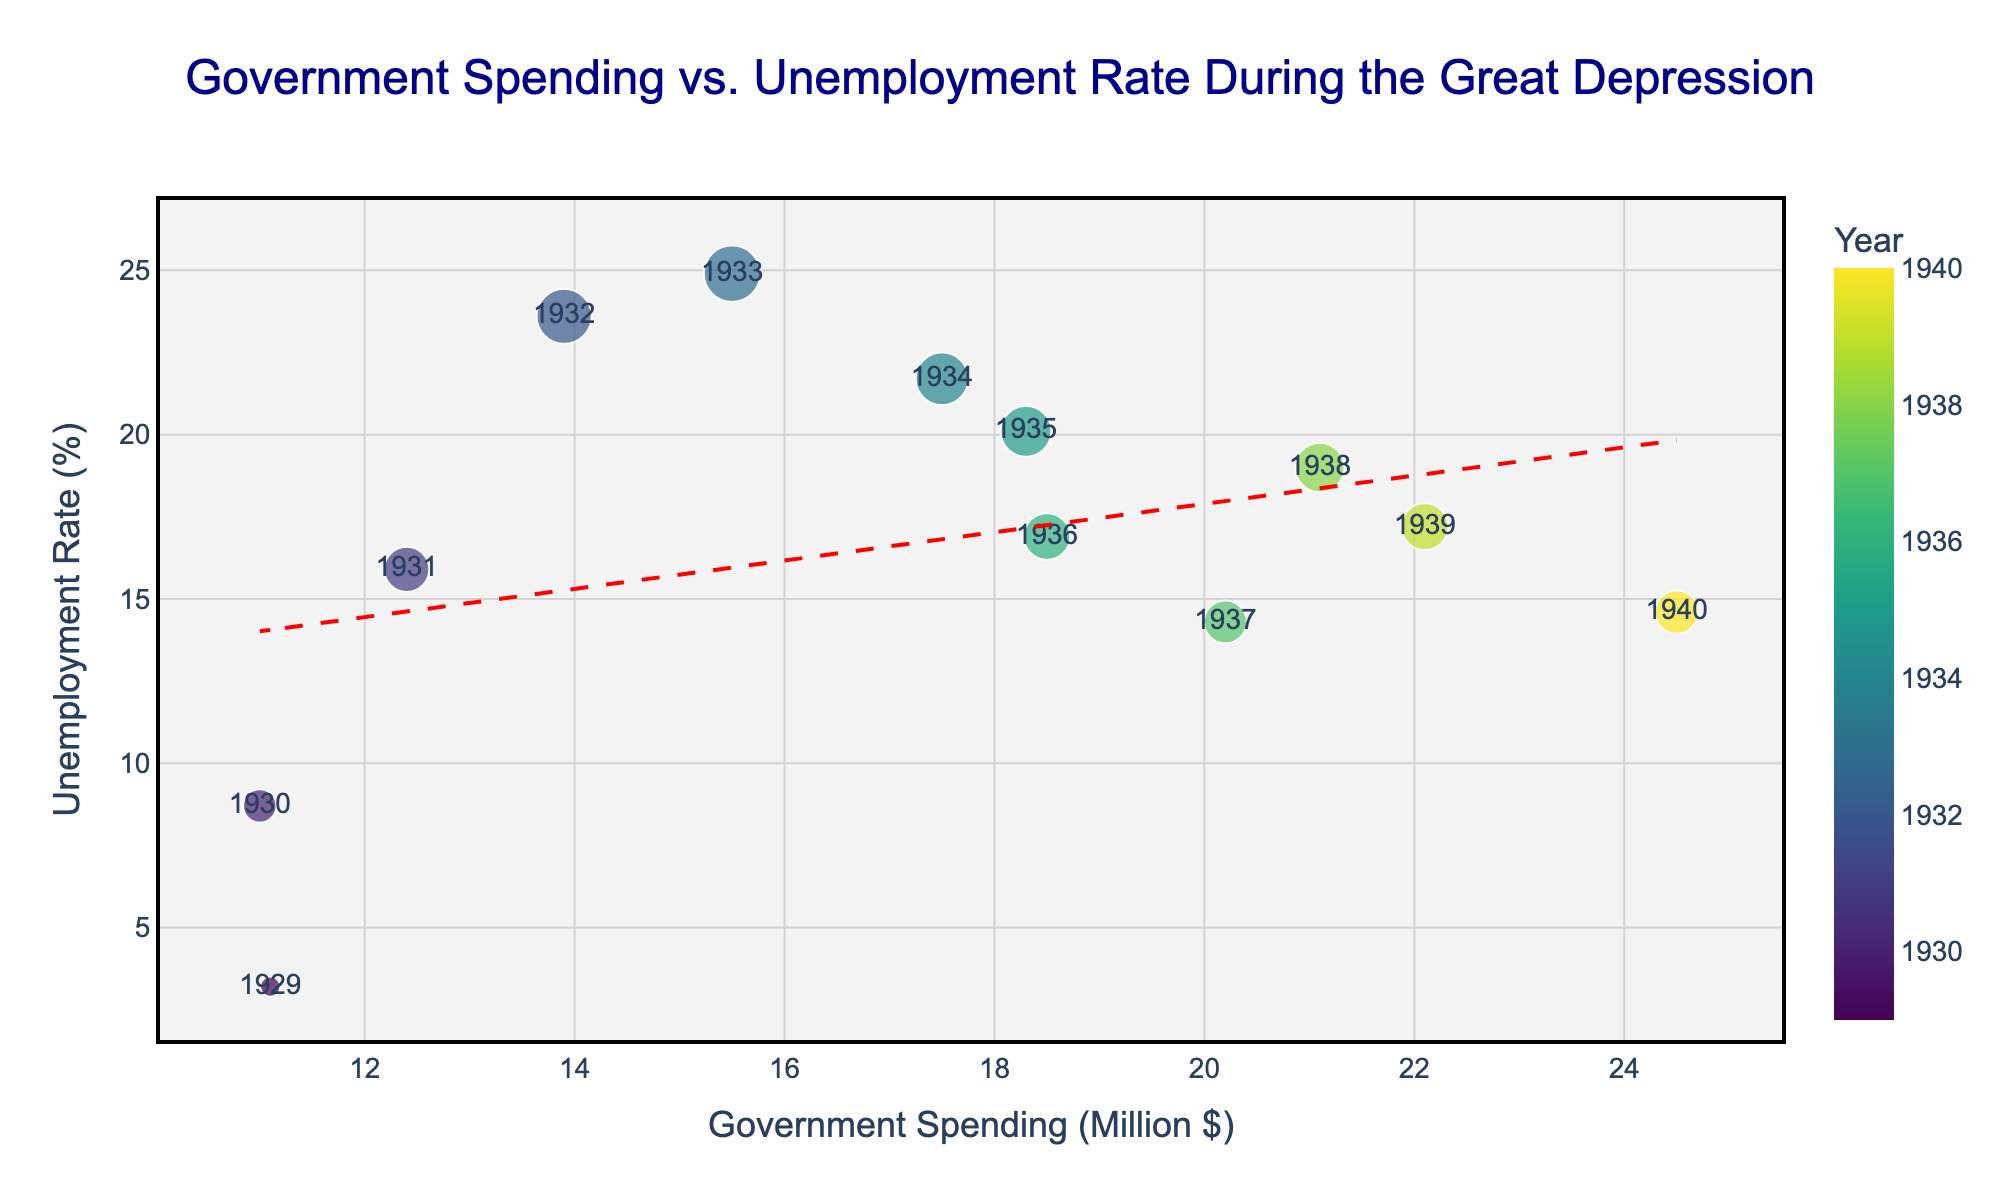What is the title of the figure? The title is usually displayed at the top of the figure, and here it clearly states the focus of the plot and the time period being examined.
Answer: Government Spending vs. Unemployment Rate During the Great Depression What do the x-axis and y-axis represent? The x-axis title represents "Government Spending (Million $)" indicating it's the variable for horizontal placement, while the y-axis title, "Unemployment Rate (%)", signifies the variable for vertical placement.
Answer: Government Spending (Million $) and Unemployment Rate (%) How many data points are represented in the figure? Each year from 1929 to 1940 represents a unique data point on the scatter plot. By counting the distinct years mentioned, we find there are 12 data points.
Answer: 12 What is the trend line suggesting about the relationship between government spending and the unemployment rate? The trend line shows the overall direction of the data. Here, it is descending from left to right, suggesting an inverse relationship: as government spending increases, unemployment rates tend to decrease.
Answer: Inverse relationship Which two years show the highest and the lowest unemployment rates? By examining the y-axis values (Unemployment Rate) for each data point, 1933 has the highest rate (24.9%) and 1929 has the lowest (3.2%).
Answer: 1933 and 1929 What approximate unemployment rate corresponds to the government spending of approximately $15 million? Identify the x-axis value close to $15 million and trace the corresponding y-axis value. The point around $15 million shows an unemployment rate near 24.9%, which is in 1933.
Answer: ~24.9% In which year did the government spending reach $24.5 million, and what was the unemployment rate then? Check the point at $24.5 million on the x-axis and look at the corresponding data label for year and the y-axis value. The year is 1940 and the unemployment rate was 14.6%.
Answer: 1940, 14.6% What year stands out as an anomaly in the context of government spending and unemployment rate, and why? An anomalous year significantly deviates from the trend. 1933 stands out because it shows the highest unemployment rate (24.9%) despite increasing government spending.
Answer: 1933, high unemployment Compare the government spending and unemployment rates between 1932 and 1937. Examine and compare the data points for the two years. 1932 shows $13.9 million spending with a 23.6% unemployment rate, while 1937 shows $20.2 million spending with a 14.3% unemployment rate. So, higher spending and lower unemployment in 1937.
Answer: 1932: $13.9M, 23.6%; 1937: $20.2M, 14.3% What general trend can be observed regarding government spending and unemployment rates during the last three years of the data? Checking the data points for 1938, 1939, and 1940, observe that government spending consistently increases ($21.1M to $24.5M) and unemployment rates generally decrease (19% to 14.6%).
Answer: Increasing spending, decreasing unemployment 